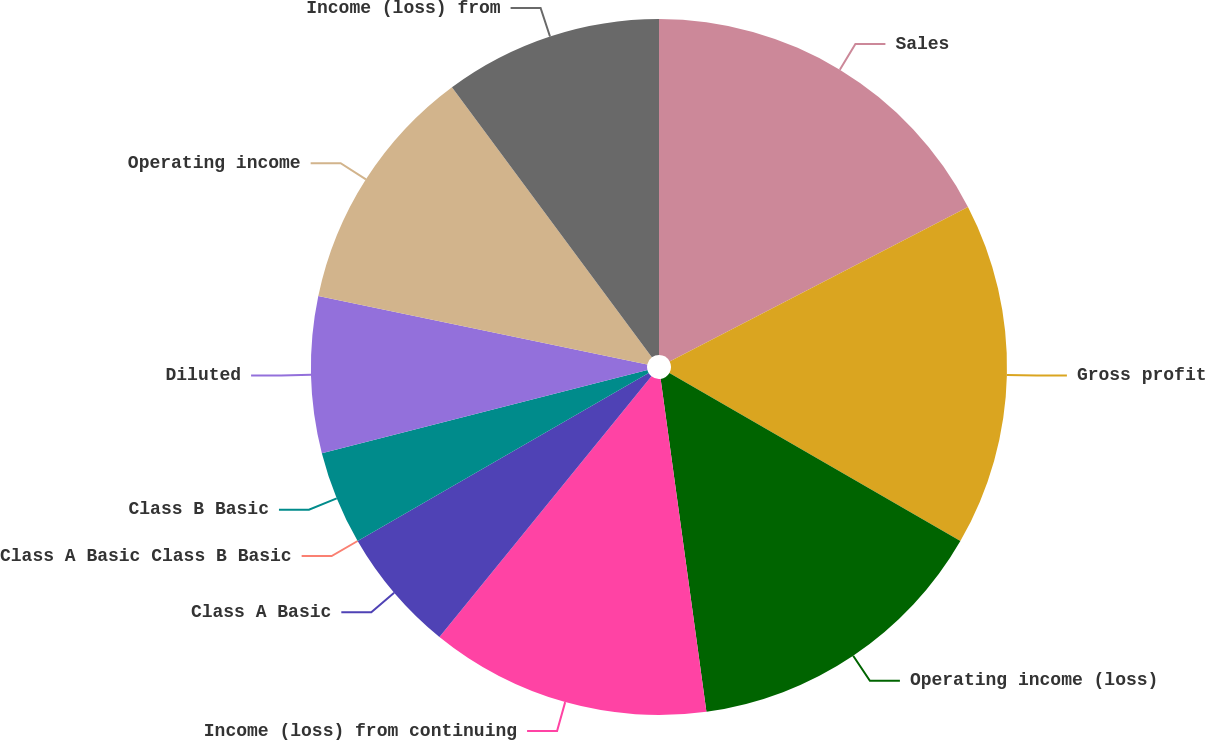Convert chart. <chart><loc_0><loc_0><loc_500><loc_500><pie_chart><fcel>Sales<fcel>Gross profit<fcel>Operating income (loss)<fcel>Income (loss) from continuing<fcel>Class A Basic<fcel>Class A Basic Class B Basic<fcel>Class B Basic<fcel>Diluted<fcel>Operating income<fcel>Income (loss) from<nl><fcel>17.39%<fcel>15.94%<fcel>14.49%<fcel>13.04%<fcel>5.8%<fcel>0.0%<fcel>4.35%<fcel>7.25%<fcel>11.59%<fcel>10.14%<nl></chart> 